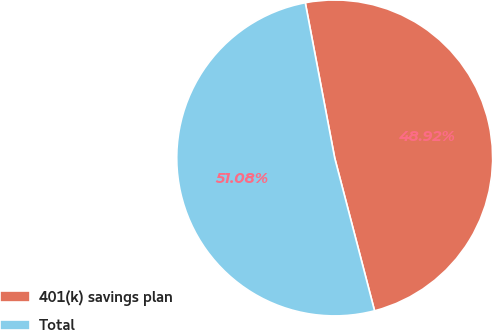Convert chart. <chart><loc_0><loc_0><loc_500><loc_500><pie_chart><fcel>401(k) savings plan<fcel>Total<nl><fcel>48.92%<fcel>51.08%<nl></chart> 